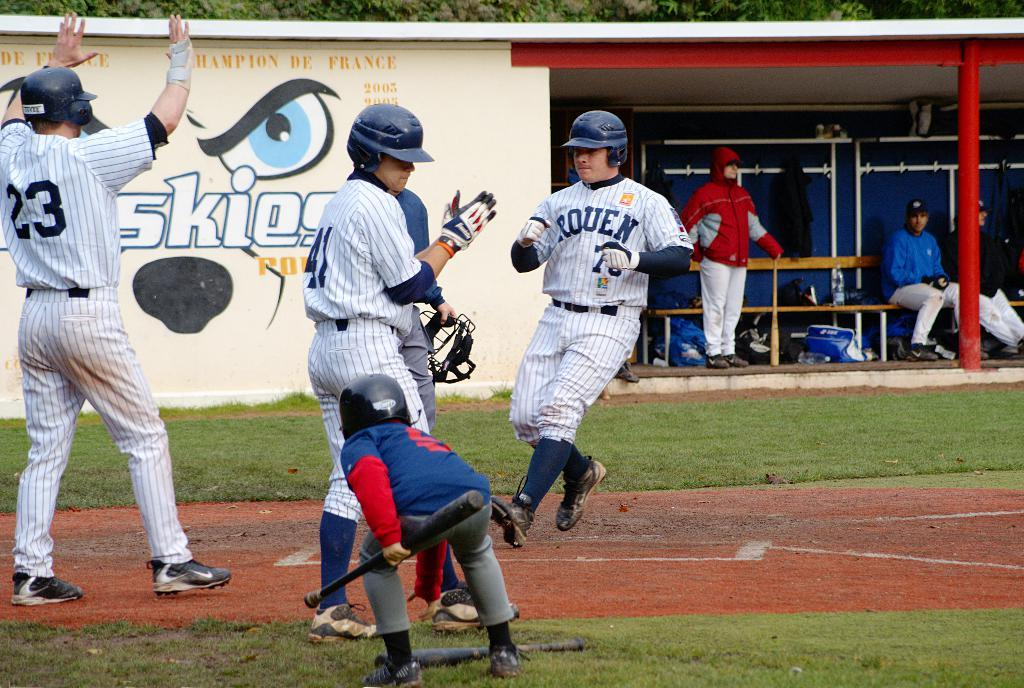<image>
Create a compact narrative representing the image presented. Ball players in white striped uniforms with RQUEN on the front in blue. 